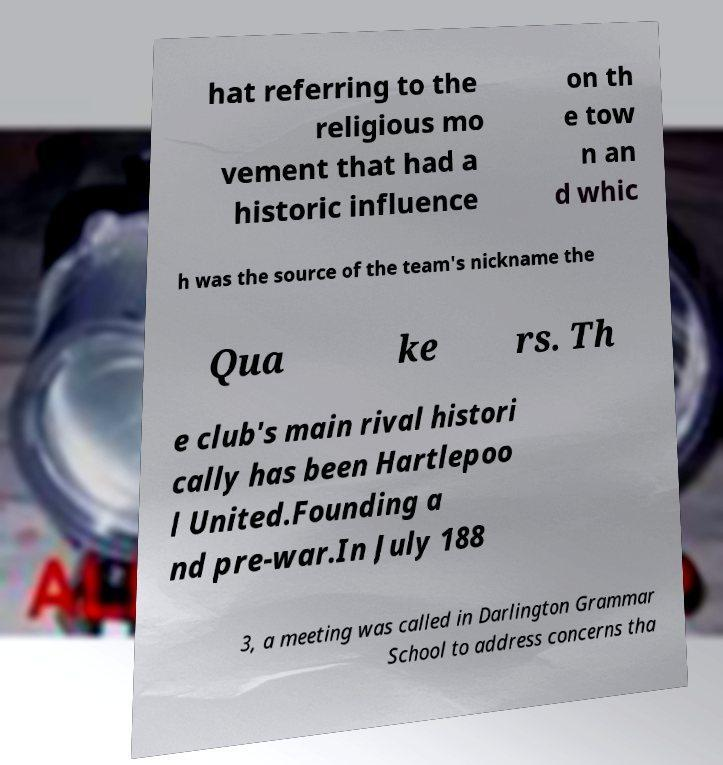What messages or text are displayed in this image? I need them in a readable, typed format. hat referring to the religious mo vement that had a historic influence on th e tow n an d whic h was the source of the team's nickname the Qua ke rs. Th e club's main rival histori cally has been Hartlepoo l United.Founding a nd pre-war.In July 188 3, a meeting was called in Darlington Grammar School to address concerns tha 